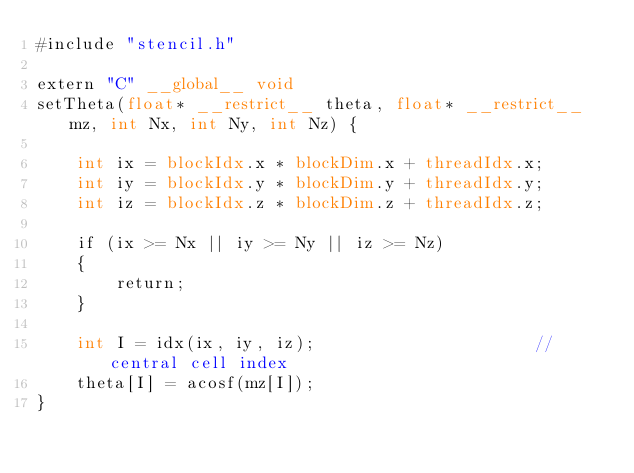Convert code to text. <code><loc_0><loc_0><loc_500><loc_500><_Cuda_>#include "stencil.h"

extern "C" __global__ void
setTheta(float* __restrict__ theta, float* __restrict__ mz, int Nx, int Ny, int Nz) {

    int ix = blockIdx.x * blockDim.x + threadIdx.x;
    int iy = blockIdx.y * blockDim.y + threadIdx.y;
    int iz = blockIdx.z * blockDim.z + threadIdx.z;

    if (ix >= Nx || iy >= Ny || iz >= Nz)
    {
        return;
    }

    int I = idx(ix, iy, iz);                      // central cell index
    theta[I] = acosf(mz[I]);
}</code> 